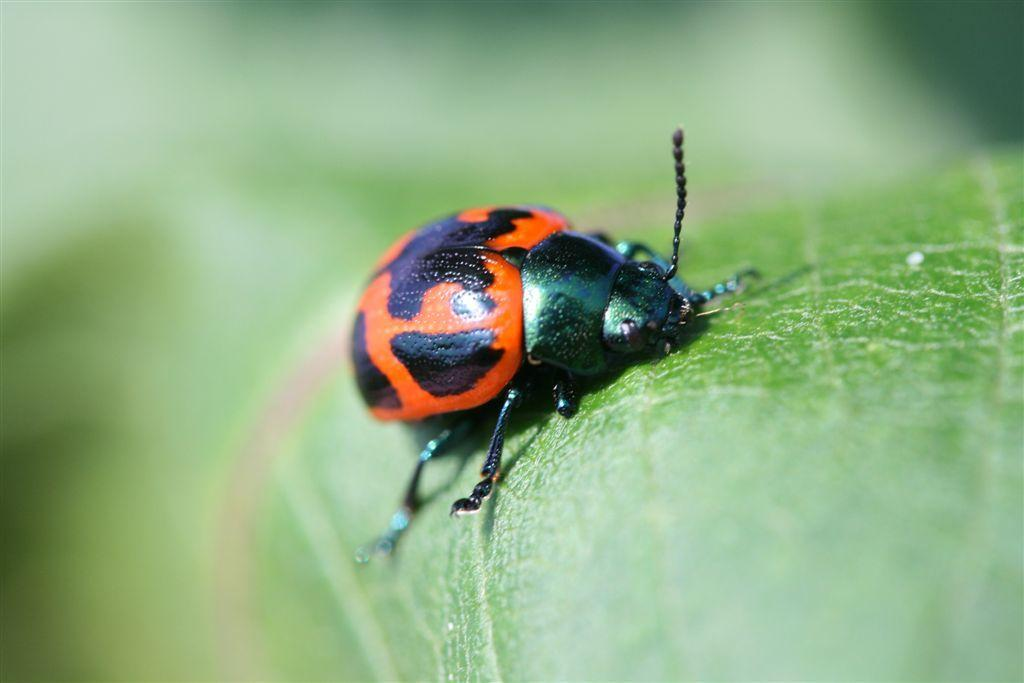What type of insect is in the image? There is a ladybird beetle in the image. Where is the ladybird beetle located in the image? The ladybird beetle is on a leaf. What type of plane can be seen in the image? There is no plane present in the image; it features a ladybird beetle on a leaf. What point is the ladybird beetle trying to make in the image? The image does not suggest that the ladybird beetle is trying to make any point; it simply shows the beetle on a leaf. 